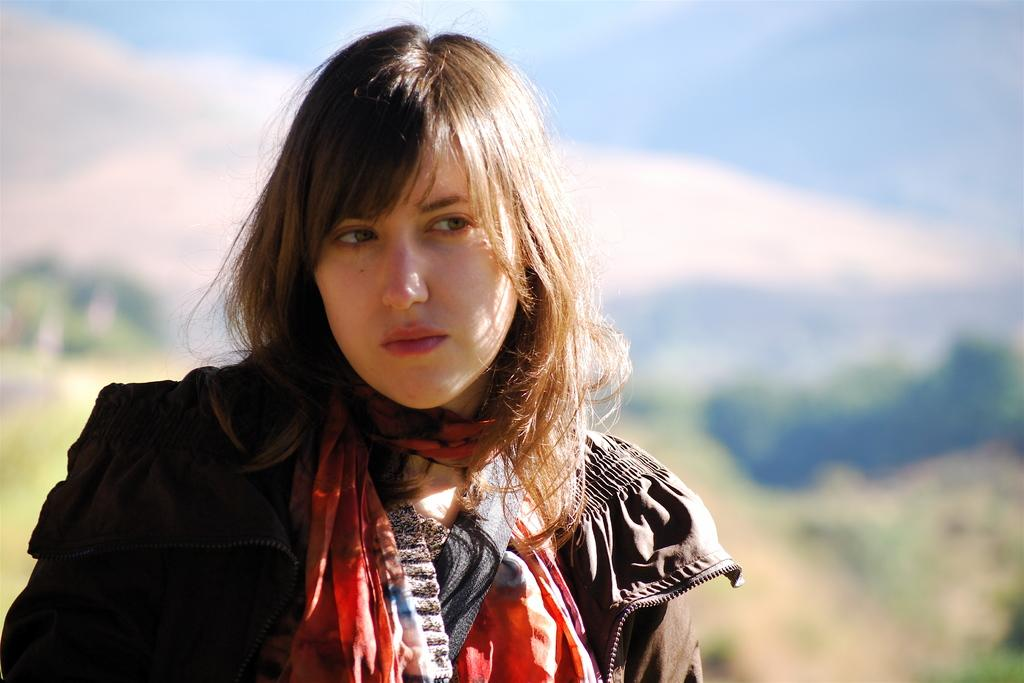Who is the main subject in the image? There is a woman in the image. What is the woman doing in the image? The woman is standing. What is the woman wearing in the image? The woman is wearing a black coat. How would you describe the sky in the image? The sky is blue and cloudy in the image. What day of the week is it in the image? The day of the week is not mentioned or visible in the image, so it cannot be determined. 